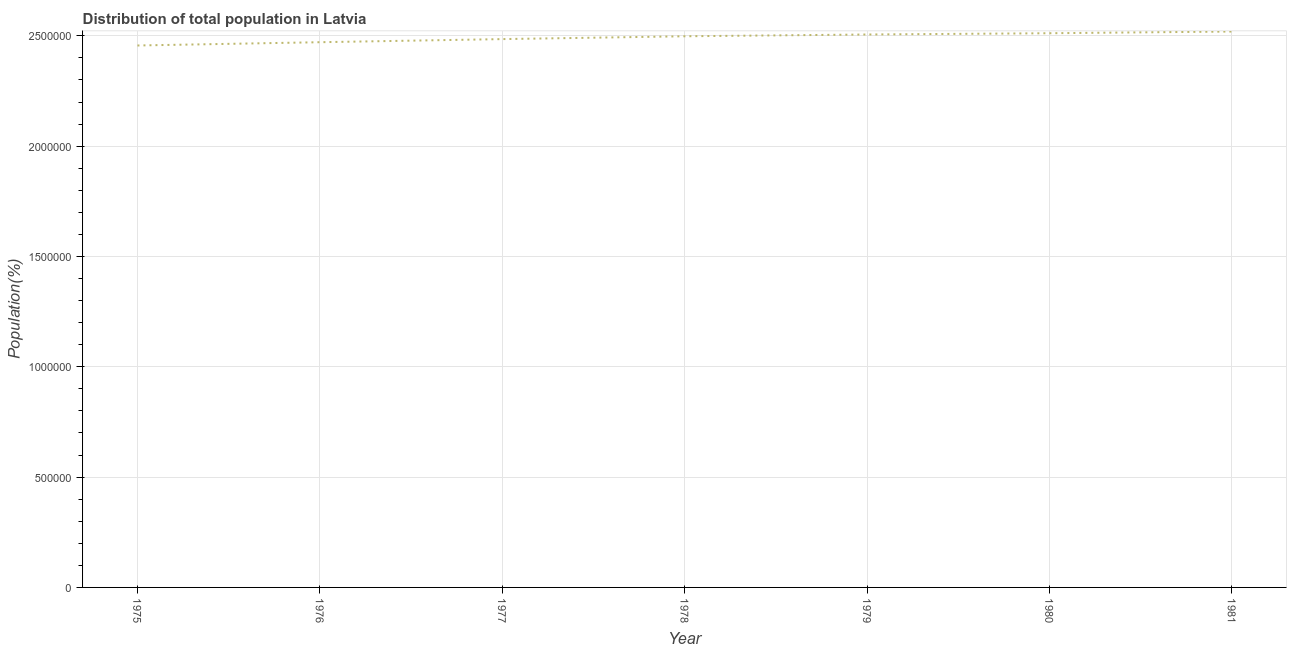What is the population in 1981?
Offer a terse response. 2.52e+06. Across all years, what is the maximum population?
Provide a short and direct response. 2.52e+06. Across all years, what is the minimum population?
Provide a succinct answer. 2.46e+06. In which year was the population minimum?
Provide a short and direct response. 1975. What is the sum of the population?
Provide a succinct answer. 1.74e+07. What is the difference between the population in 1976 and 1978?
Make the answer very short. -2.69e+04. What is the average population per year?
Give a very brief answer. 2.49e+06. What is the median population?
Make the answer very short. 2.50e+06. Do a majority of the years between 1979 and 1975 (inclusive) have population greater than 400000 %?
Give a very brief answer. Yes. What is the ratio of the population in 1977 to that in 1980?
Your answer should be compact. 0.99. Is the difference between the population in 1975 and 1977 greater than the difference between any two years?
Keep it short and to the point. No. What is the difference between the highest and the second highest population?
Your response must be concise. 7720. Is the sum of the population in 1980 and 1981 greater than the maximum population across all years?
Give a very brief answer. Yes. What is the difference between the highest and the lowest population?
Give a very brief answer. 6.33e+04. In how many years, is the population greater than the average population taken over all years?
Your answer should be very brief. 4. How many lines are there?
Make the answer very short. 1. How many years are there in the graph?
Offer a very short reply. 7. Are the values on the major ticks of Y-axis written in scientific E-notation?
Provide a short and direct response. No. Does the graph contain any zero values?
Ensure brevity in your answer.  No. What is the title of the graph?
Your answer should be compact. Distribution of total population in Latvia . What is the label or title of the Y-axis?
Your answer should be very brief. Population(%). What is the Population(%) of 1975?
Your answer should be very brief. 2.46e+06. What is the Population(%) of 1976?
Keep it short and to the point. 2.47e+06. What is the Population(%) of 1977?
Keep it short and to the point. 2.49e+06. What is the Population(%) in 1978?
Make the answer very short. 2.50e+06. What is the Population(%) of 1979?
Make the answer very short. 2.51e+06. What is the Population(%) in 1980?
Ensure brevity in your answer.  2.51e+06. What is the Population(%) in 1981?
Your response must be concise. 2.52e+06. What is the difference between the Population(%) in 1975 and 1976?
Offer a terse response. -1.49e+04. What is the difference between the Population(%) in 1975 and 1977?
Ensure brevity in your answer.  -2.89e+04. What is the difference between the Population(%) in 1975 and 1978?
Your answer should be very brief. -4.18e+04. What is the difference between the Population(%) in 1975 and 1979?
Offer a terse response. -4.98e+04. What is the difference between the Population(%) in 1975 and 1980?
Your answer should be compact. -5.56e+04. What is the difference between the Population(%) in 1975 and 1981?
Make the answer very short. -6.33e+04. What is the difference between the Population(%) in 1976 and 1977?
Make the answer very short. -1.41e+04. What is the difference between the Population(%) in 1976 and 1978?
Your answer should be compact. -2.69e+04. What is the difference between the Population(%) in 1976 and 1979?
Keep it short and to the point. -3.50e+04. What is the difference between the Population(%) in 1976 and 1980?
Make the answer very short. -4.07e+04. What is the difference between the Population(%) in 1976 and 1981?
Ensure brevity in your answer.  -4.84e+04. What is the difference between the Population(%) in 1977 and 1978?
Your answer should be compact. -1.28e+04. What is the difference between the Population(%) in 1977 and 1979?
Ensure brevity in your answer.  -2.09e+04. What is the difference between the Population(%) in 1977 and 1980?
Your answer should be compact. -2.66e+04. What is the difference between the Population(%) in 1977 and 1981?
Your answer should be very brief. -3.43e+04. What is the difference between the Population(%) in 1978 and 1979?
Offer a very short reply. -8032. What is the difference between the Population(%) in 1978 and 1980?
Provide a short and direct response. -1.38e+04. What is the difference between the Population(%) in 1978 and 1981?
Your answer should be compact. -2.15e+04. What is the difference between the Population(%) in 1979 and 1980?
Ensure brevity in your answer.  -5748. What is the difference between the Population(%) in 1979 and 1981?
Ensure brevity in your answer.  -1.35e+04. What is the difference between the Population(%) in 1980 and 1981?
Offer a terse response. -7720. What is the ratio of the Population(%) in 1975 to that in 1976?
Give a very brief answer. 0.99. What is the ratio of the Population(%) in 1975 to that in 1977?
Offer a terse response. 0.99. What is the ratio of the Population(%) in 1975 to that in 1978?
Make the answer very short. 0.98. What is the ratio of the Population(%) in 1975 to that in 1979?
Provide a succinct answer. 0.98. What is the ratio of the Population(%) in 1975 to that in 1980?
Keep it short and to the point. 0.98. What is the ratio of the Population(%) in 1976 to that in 1979?
Make the answer very short. 0.99. What is the ratio of the Population(%) in 1976 to that in 1980?
Ensure brevity in your answer.  0.98. What is the ratio of the Population(%) in 1976 to that in 1981?
Your answer should be very brief. 0.98. What is the ratio of the Population(%) in 1978 to that in 1979?
Your answer should be compact. 1. What is the ratio of the Population(%) in 1978 to that in 1980?
Your response must be concise. 0.99. 